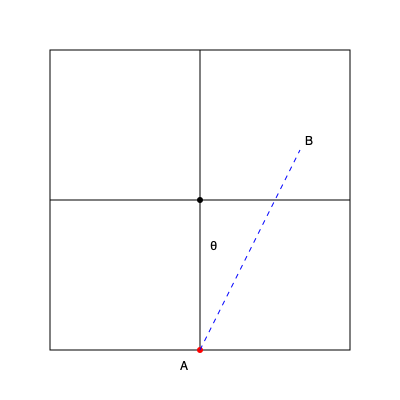In a badminton court, player A at the center of the baseline aims to hit a clear shot to the back corner of the opposite court (point B). If the court is 13.4 meters long and 6.1 meters wide, what is the angle θ (in degrees) that the shuttlecock's trajectory makes with the vertical axis? To solve this problem, we need to follow these steps:

1. Identify the right triangle formed by the trajectory:
   - The vertical side is half the court length: $13.4/2 = 6.7$ meters
   - The horizontal side is half the court width: $6.1/2 = 3.05$ meters

2. Use the arctangent function to calculate the angle:
   $θ = \arctan(\frac{\text{opposite}}{\text{adjacent}})$

3. Plug in the values:
   $θ = \arctan(\frac{3.05}{6.7})$

4. Calculate:
   $θ = \arctan(0.4552)$

5. Convert to degrees:
   $θ = 24.44°$

Therefore, the angle θ that the shuttlecock's trajectory makes with the vertical axis is approximately 24.44 degrees.
Answer: 24.44° 